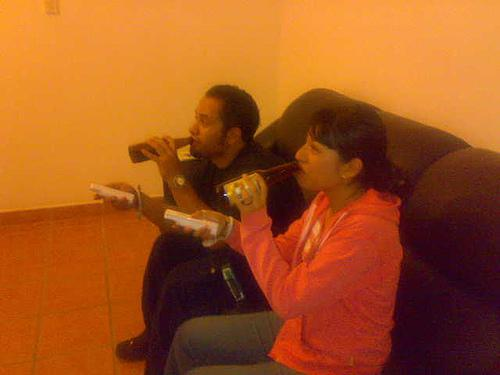Question: where are the people seated?
Choices:
A. At the table.
B. In a bed.
C. On a sofa.
D. On the floor.
Answer with the letter. Answer: C Question: what are the people doing?
Choices:
A. Playing video games.
B. Watching TV.
C. Listening to the radio.
D. Playing a board game.
Answer with the letter. Answer: A Question: how many women are in this picture?
Choices:
A. One.
B. Three.
C. Six.
D. Two.
Answer with the letter. Answer: A Question: what color are the video game controlers?
Choices:
A. Gray.
B. Black.
C. White.
D. Silver.
Answer with the letter. Answer: C 